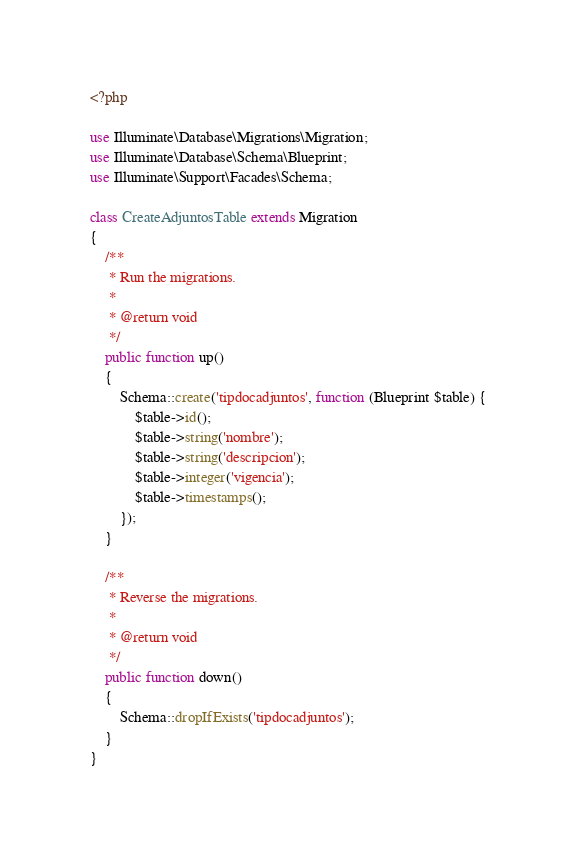<code> <loc_0><loc_0><loc_500><loc_500><_PHP_><?php

use Illuminate\Database\Migrations\Migration;
use Illuminate\Database\Schema\Blueprint;
use Illuminate\Support\Facades\Schema;

class CreateAdjuntosTable extends Migration
{
    /**
     * Run the migrations.
     *
     * @return void
     */
    public function up()
    {
        Schema::create('tipdocadjuntos', function (Blueprint $table) {
            $table->id();
            $table->string('nombre');
            $table->string('descripcion');
            $table->integer('vigencia');
            $table->timestamps();
        });
    }

    /**
     * Reverse the migrations.
     *
     * @return void
     */
    public function down()
    {
        Schema::dropIfExists('tipdocadjuntos');
    }
}
</code> 